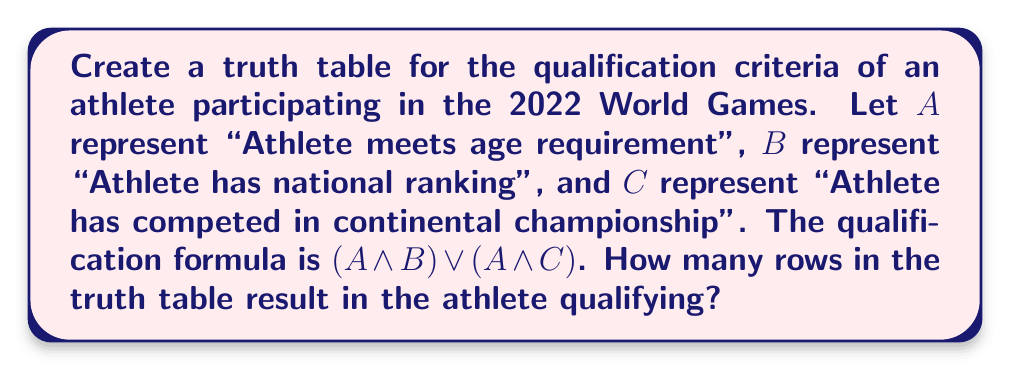Could you help me with this problem? Let's create the truth table step-by-step:

1) First, we list all possible combinations of A, B, and C:

   A | B | C
   ---|---|---
   0 | 0 | 0
   0 | 0 | 1
   0 | 1 | 0
   0 | 1 | 1
   1 | 0 | 0
   1 | 0 | 1
   1 | 1 | 0
   1 | 1 | 1

2) Now, let's evaluate $(A \land B)$:

   A | B | C | (A ∧ B)
   ---|---|---|-------
   0 | 0 | 0 |   0
   0 | 0 | 1 |   0
   0 | 1 | 0 |   0
   0 | 1 | 1 |   0
   1 | 0 | 0 |   0
   1 | 0 | 1 |   0
   1 | 1 | 0 |   1
   1 | 1 | 1 |   1

3) Next, let's evaluate $(A \land C)$:

   A | B | C | (A ∧ B) | (A ∧ C)
   ---|---|---|--------|--------
   0 | 0 | 0 |   0    |    0
   0 | 0 | 1 |   0    |    0
   0 | 1 | 0 |   0    |    0
   0 | 1 | 1 |   0    |    0
   1 | 0 | 0 |   0    |    0
   1 | 0 | 1 |   0    |    1
   1 | 1 | 0 |   1    |    0
   1 | 1 | 1 |   1    |    1

4) Finally, we evaluate $(A \land B) \lor (A \land C)$:

   A | B | C | (A ∧ B) | (A ∧ C) | (A ∧ B) ∨ (A ∧ C)
   ---|---|---|--------|--------|-------------------
   0 | 0 | 0 |   0    |    0    |         0
   0 | 0 | 1 |   0    |    0    |         0
   0 | 1 | 0 |   0    |    0    |         0
   0 | 1 | 1 |   0    |    0    |         0
   1 | 0 | 0 |   0    |    0    |         0
   1 | 0 | 1 |   0    |    1    |         1
   1 | 1 | 0 |   1    |    0    |         1
   1 | 1 | 1 |   1    |    1    |         1

5) Count the number of rows where the final result is 1 (true).

There are 3 rows where the result is 1, meaning the athlete qualifies in 3 scenarios.
Answer: 3 